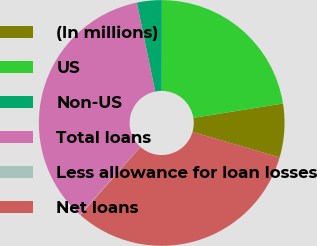Convert chart to OTSL. <chart><loc_0><loc_0><loc_500><loc_500><pie_chart><fcel>(In millions)<fcel>US<fcel>Non-US<fcel>Total loans<fcel>Less allowance for loan losses<fcel>Net loans<nl><fcel>7.05%<fcel>22.45%<fcel>3.26%<fcel>35.19%<fcel>0.06%<fcel>31.99%<nl></chart> 